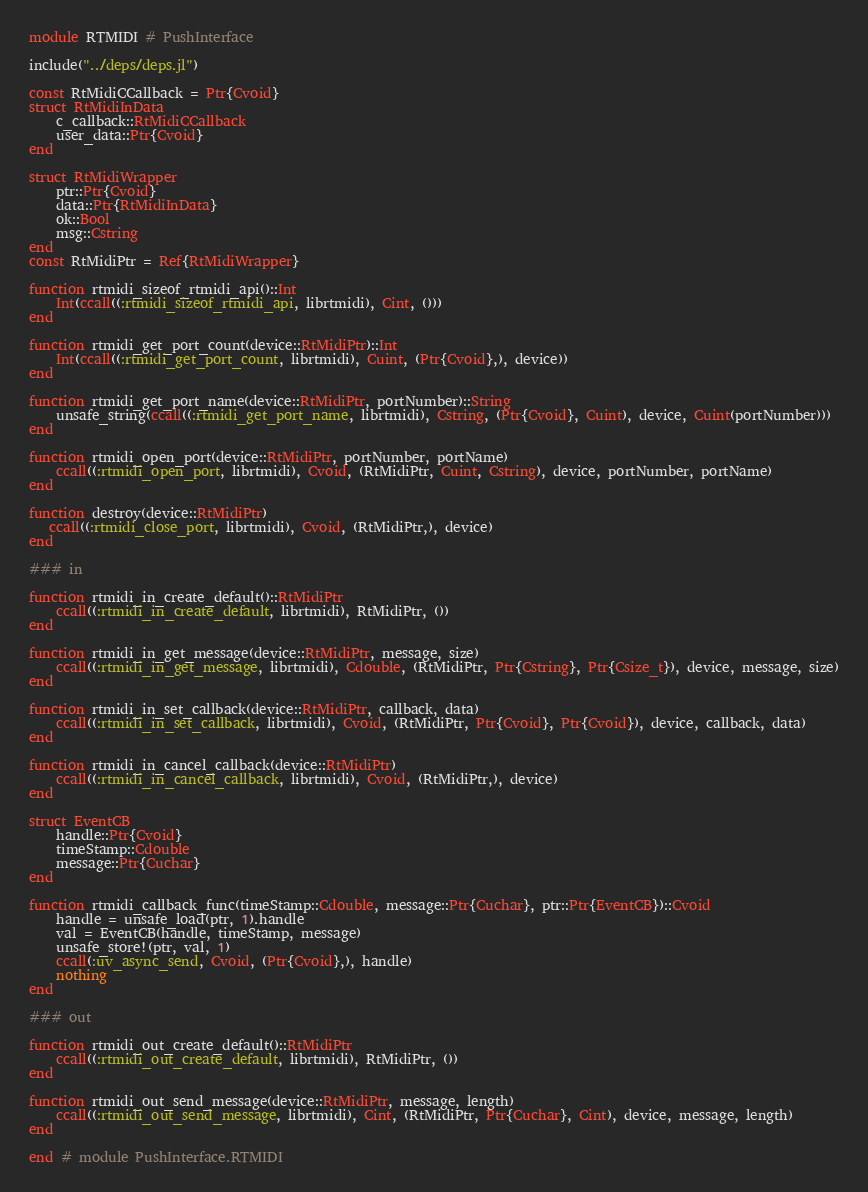<code> <loc_0><loc_0><loc_500><loc_500><_Julia_>module RTMIDI # PushInterface

include("../deps/deps.jl")

const RtMidiCCallback = Ptr{Cvoid} 
struct RtMidiInData
    c_callback::RtMidiCCallback
    user_data::Ptr{Cvoid}
end

struct RtMidiWrapper
    ptr::Ptr{Cvoid}
    data::Ptr{RtMidiInData}
    ok::Bool
    msg::Cstring
end
const RtMidiPtr = Ref{RtMidiWrapper}

function rtmidi_sizeof_rtmidi_api()::Int
    Int(ccall((:rtmidi_sizeof_rtmidi_api, librtmidi), Cint, ()))
end

function rtmidi_get_port_count(device::RtMidiPtr)::Int
    Int(ccall((:rtmidi_get_port_count, librtmidi), Cuint, (Ptr{Cvoid},), device))
end

function rtmidi_get_port_name(device::RtMidiPtr, portNumber)::String
    unsafe_string(ccall((:rtmidi_get_port_name, librtmidi), Cstring, (Ptr{Cvoid}, Cuint), device, Cuint(portNumber)))
end

function rtmidi_open_port(device::RtMidiPtr, portNumber, portName)
    ccall((:rtmidi_open_port, librtmidi), Cvoid, (RtMidiPtr, Cuint, Cstring), device, portNumber, portName)
end

function destroy(device::RtMidiPtr)
   ccall((:rtmidi_close_port, librtmidi), Cvoid, (RtMidiPtr,), device)
end

### in

function rtmidi_in_create_default()::RtMidiPtr
    ccall((:rtmidi_in_create_default, librtmidi), RtMidiPtr, ())
end

function rtmidi_in_get_message(device::RtMidiPtr, message, size)
    ccall((:rtmidi_in_get_message, librtmidi), Cdouble, (RtMidiPtr, Ptr{Cstring}, Ptr{Csize_t}), device, message, size)
end

function rtmidi_in_set_callback(device::RtMidiPtr, callback, data)
    ccall((:rtmidi_in_set_callback, librtmidi), Cvoid, (RtMidiPtr, Ptr{Cvoid}, Ptr{Cvoid}), device, callback, data)
end

function rtmidi_in_cancel_callback(device::RtMidiPtr)
    ccall((:rtmidi_in_cancel_callback, librtmidi), Cvoid, (RtMidiPtr,), device)
end

struct EventCB
    handle::Ptr{Cvoid}
    timeStamp::Cdouble
    message::Ptr{Cuchar}
end

function rtmidi_callback_func(timeStamp::Cdouble, message::Ptr{Cuchar}, ptr::Ptr{EventCB})::Cvoid
    handle = unsafe_load(ptr, 1).handle
    val = EventCB(handle, timeStamp, message)
    unsafe_store!(ptr, val, 1)
    ccall(:uv_async_send, Cvoid, (Ptr{Cvoid},), handle)
    nothing
end

### out

function rtmidi_out_create_default()::RtMidiPtr
    ccall((:rtmidi_out_create_default, librtmidi), RtMidiPtr, ())
end

function rtmidi_out_send_message(device::RtMidiPtr, message, length)
    ccall((:rtmidi_out_send_message, librtmidi), Cint, (RtMidiPtr, Ptr{Cuchar}, Cint), device, message, length)
end

end # module PushInterface.RTMIDI
</code> 